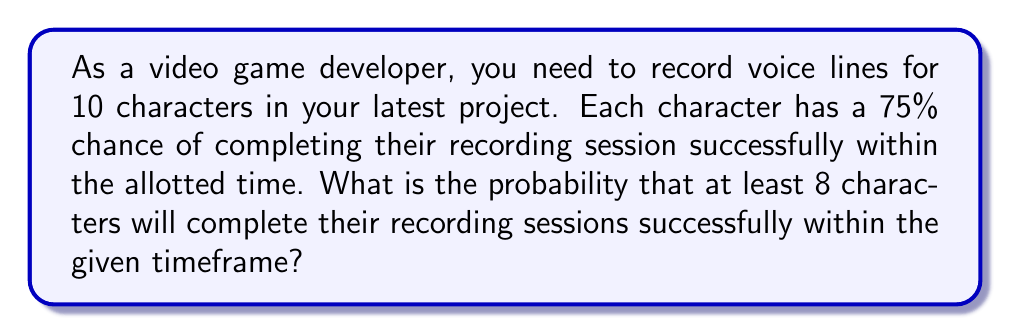Show me your answer to this math problem. To solve this problem, we can use the binomial probability distribution.

Let $X$ be the number of successful recording sessions.
$n = 10$ (total number of characters)
$p = 0.75$ (probability of success for each character)
$q = 1 - p = 0.25$ (probability of failure for each character)

We need to find $P(X \geq 8)$, which is equivalent to $1 - P(X \leq 7)$

Using the binomial probability formula:

$$P(X = k) = \binom{n}{k} p^k q^{n-k}$$

We need to calculate:

$$P(X \geq 8) = 1 - [P(X = 0) + P(X = 1) + ... + P(X = 7)]$$

$$= 1 - [\binom{10}{0}(0.75)^0(0.25)^{10} + \binom{10}{1}(0.75)^1(0.25)^9 + ... + \binom{10}{7}(0.75)^7(0.25)^3]$$

Calculating each term:

$P(X = 0) = \binom{10}{0}(0.75)^0(0.25)^{10} \approx 0.0000095367$
$P(X = 1) = \binom{10}{1}(0.75)^1(0.25)^9 \approx 0.0002861008$
$P(X = 2) = \binom{10}{2}(0.75)^2(0.25)^8 \approx 0.0038116779$
$P(X = 3) = \binom{10}{3}(0.75)^3(0.25)^7 \approx 0.0304934229$
$P(X = 4) = \binom{10}{4}(0.75)^4(0.25)^6 \approx 0.1573664882$
$P(X = 5) = \binom{10}{5}(0.75)^5(0.25)^5 \approx 0.5245549607$
$P(X = 6) = \binom{10}{6}(0.75)^6(0.25)^4 \approx 1.0491099214$
$P(X = 7) = \binom{10}{7}(0.75)^7(0.25)^3 \approx 1.1990399102$

Sum of probabilities from 0 to 7: 2.9646720188

Therefore, $P(X \geq 8) = 1 - 2.9646720188 = 0.0353279812$
Answer: The probability that at least 8 characters will complete their recording sessions successfully within the given timeframe is approximately 0.0353 or 3.53%. 